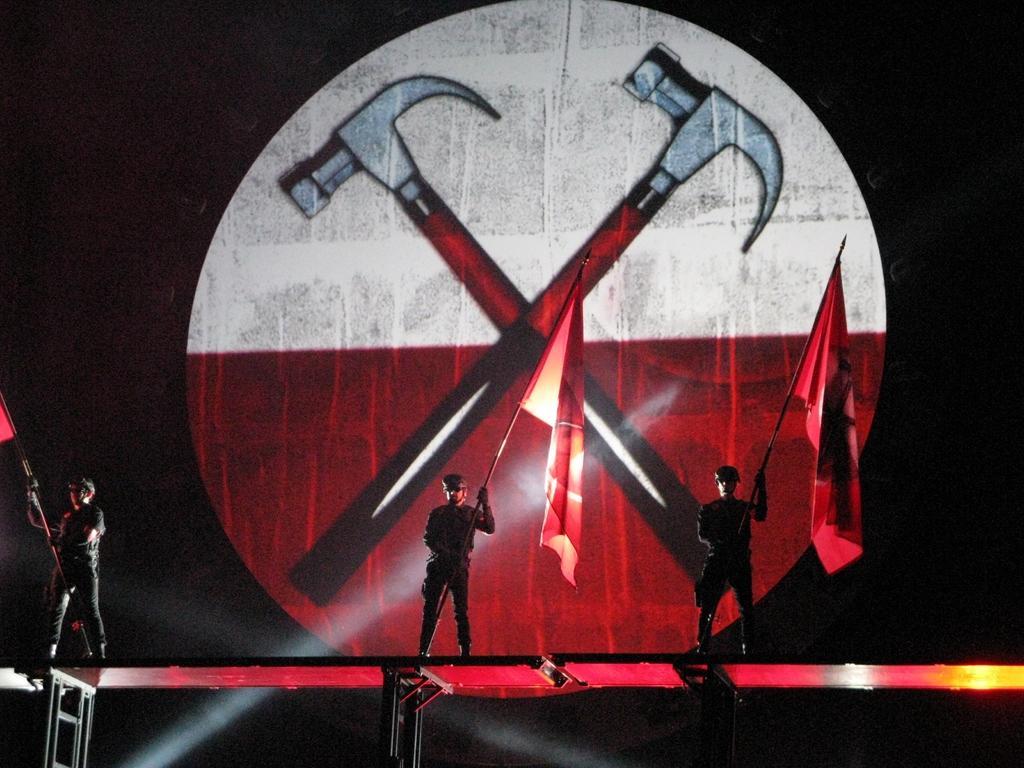Describe this image in one or two sentences. In this picture we can observe three members standing on the stage, holding three red color flags in their hands. In the background we can observe two hammers which are in black and red colors. The background is completely dark. 